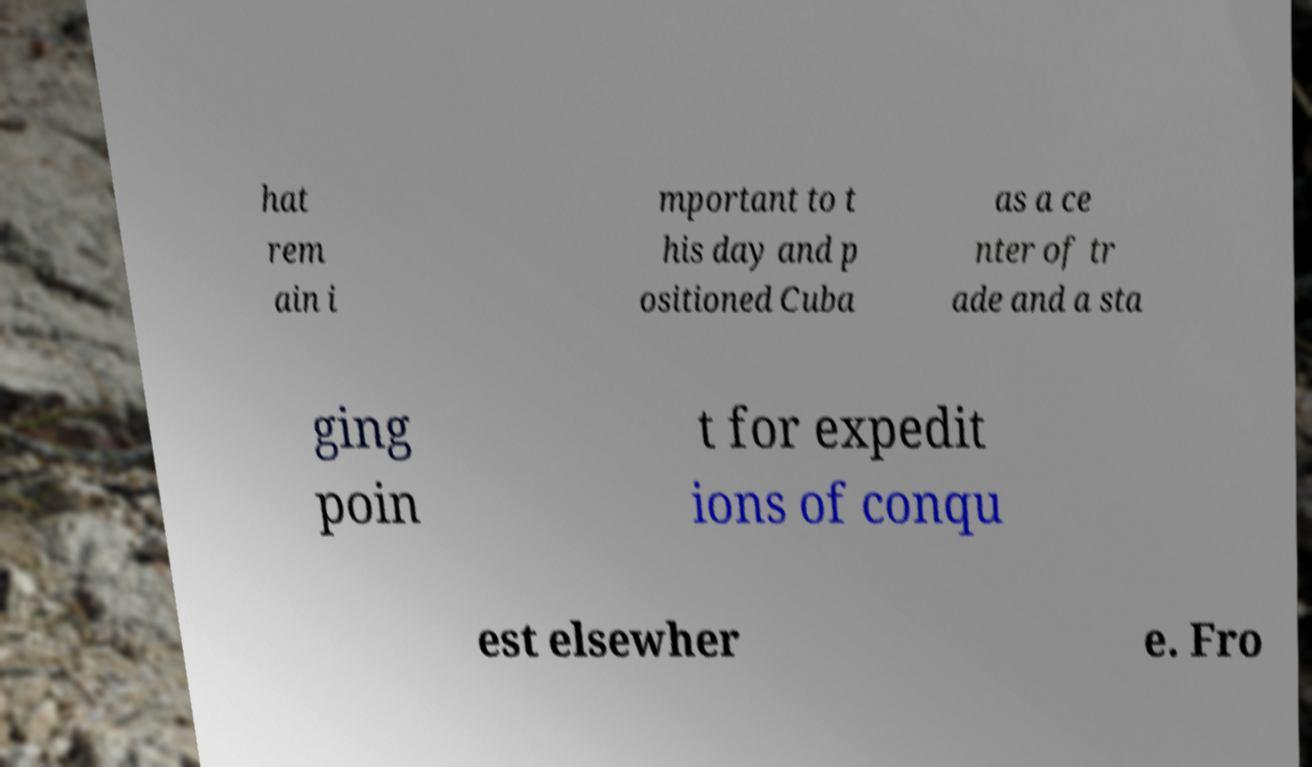Can you accurately transcribe the text from the provided image for me? hat rem ain i mportant to t his day and p ositioned Cuba as a ce nter of tr ade and a sta ging poin t for expedit ions of conqu est elsewher e. Fro 